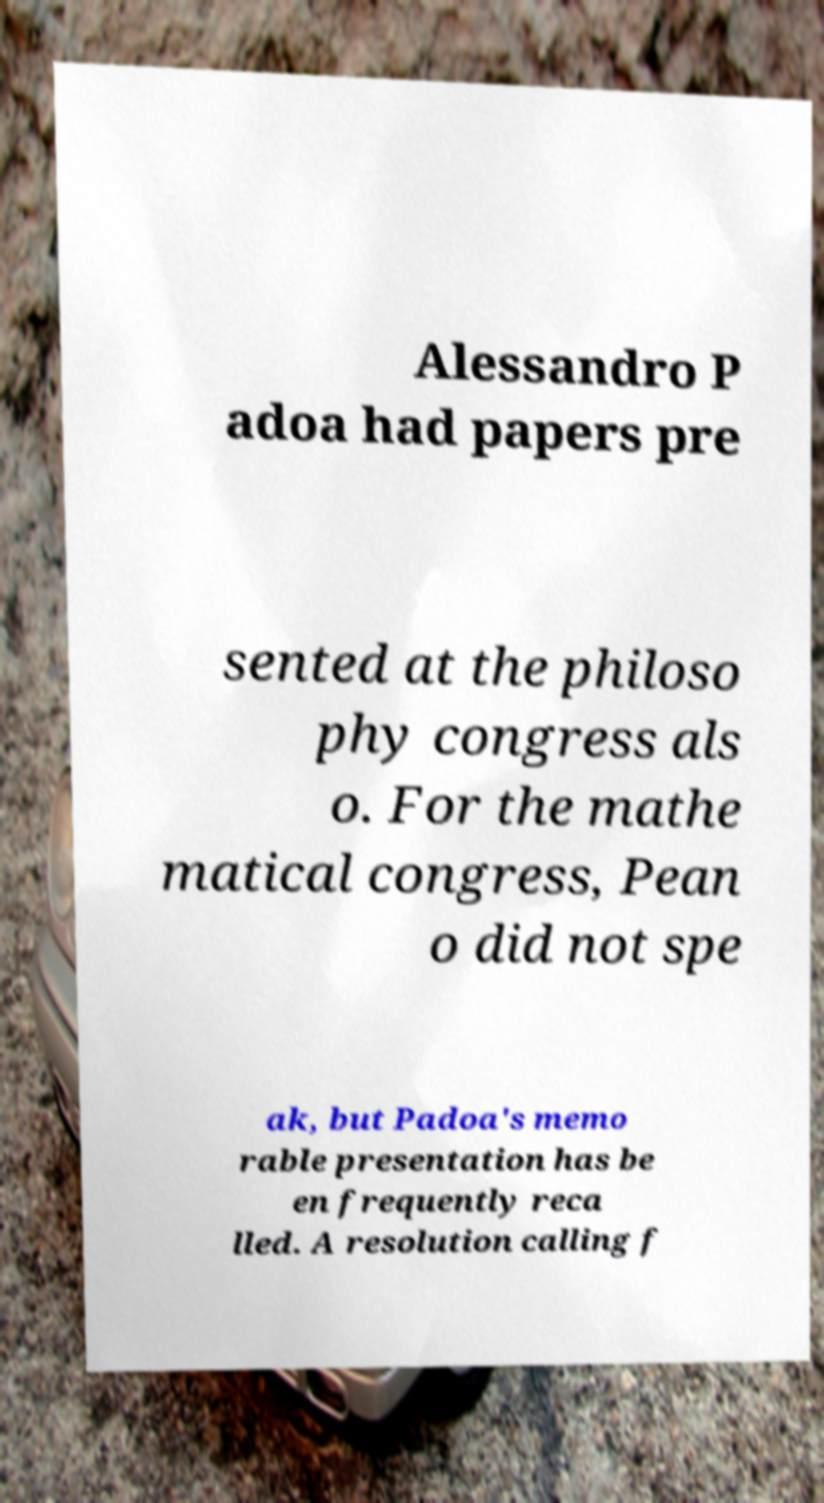Can you read and provide the text displayed in the image?This photo seems to have some interesting text. Can you extract and type it out for me? Alessandro P adoa had papers pre sented at the philoso phy congress als o. For the mathe matical congress, Pean o did not spe ak, but Padoa's memo rable presentation has be en frequently reca lled. A resolution calling f 